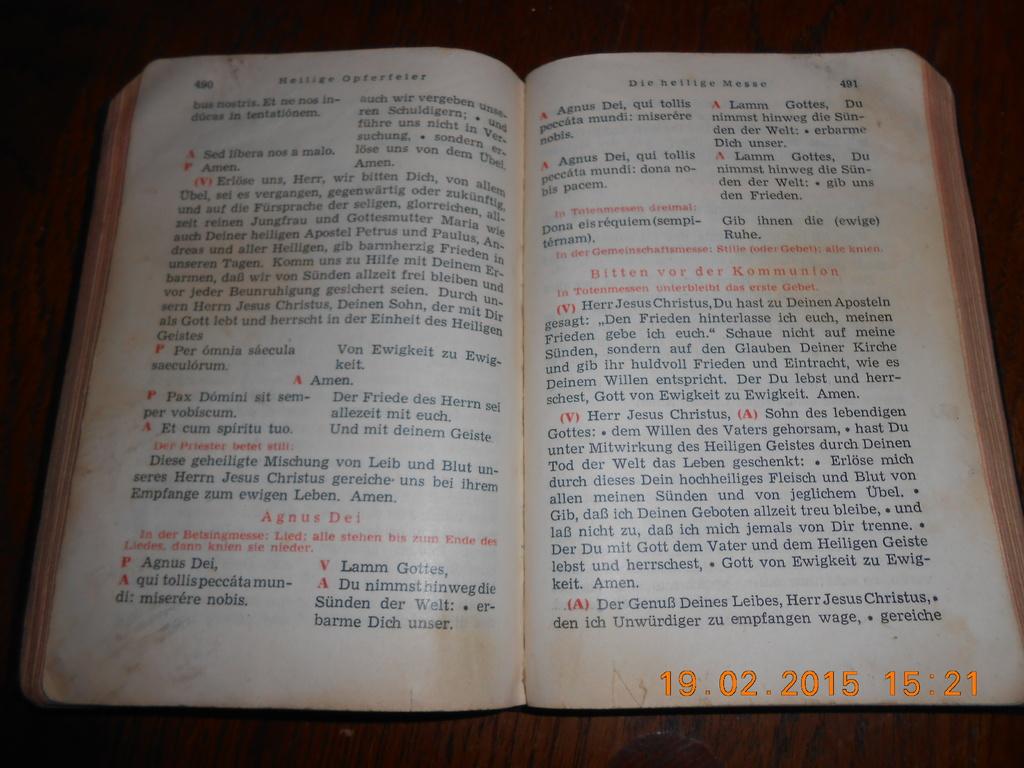What is the right page number?
Provide a succinct answer. 491. 